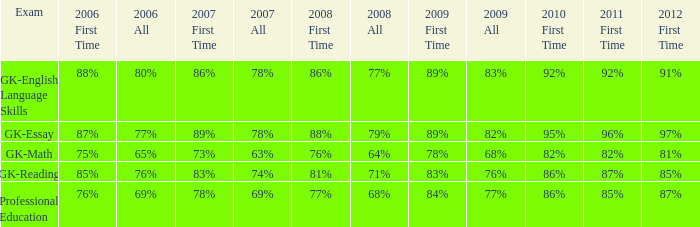Can you give me this table as a dict? {'header': ['Exam', '2006 First Time', '2006 All', '2007 First Time', '2007 All', '2008 First Time', '2008 All', '2009 First Time', '2009 All', '2010 First Time', '2011 First Time', '2012 First Time'], 'rows': [['GK-English Language Skills', '88%', '80%', '86%', '78%', '86%', '77%', '89%', '83%', '92%', '92%', '91%'], ['GK-Essay', '87%', '77%', '89%', '78%', '88%', '79%', '89%', '82%', '95%', '96%', '97%'], ['GK-Math', '75%', '65%', '73%', '63%', '76%', '64%', '78%', '68%', '82%', '82%', '81%'], ['GK-Reading', '85%', '76%', '83%', '74%', '81%', '71%', '83%', '76%', '86%', '87%', '85%'], ['Professional Education', '76%', '69%', '78%', '69%', '77%', '68%', '84%', '77%', '86%', '85%', '87%']]} What is the rate for the first instance in 2011 when the first instance in 2009 is 68%? 82%. 